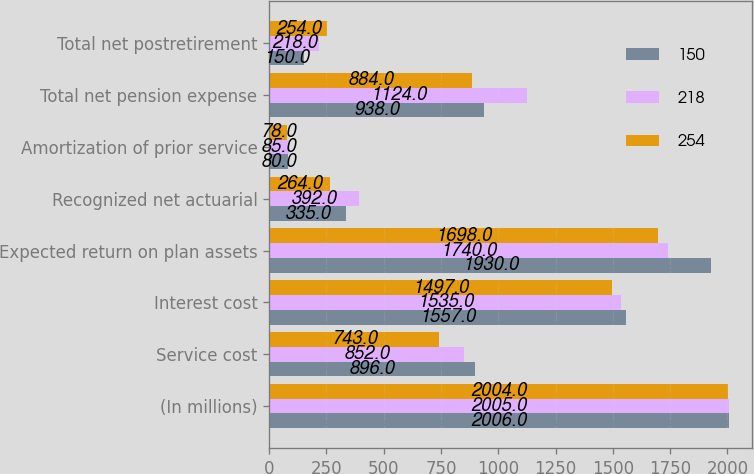Convert chart. <chart><loc_0><loc_0><loc_500><loc_500><stacked_bar_chart><ecel><fcel>(In millions)<fcel>Service cost<fcel>Interest cost<fcel>Expected return on plan assets<fcel>Recognized net actuarial<fcel>Amortization of prior service<fcel>Total net pension expense<fcel>Total net postretirement<nl><fcel>150<fcel>2006<fcel>896<fcel>1557<fcel>1930<fcel>335<fcel>80<fcel>938<fcel>150<nl><fcel>218<fcel>2005<fcel>852<fcel>1535<fcel>1740<fcel>392<fcel>85<fcel>1124<fcel>218<nl><fcel>254<fcel>2004<fcel>743<fcel>1497<fcel>1698<fcel>264<fcel>78<fcel>884<fcel>254<nl></chart> 